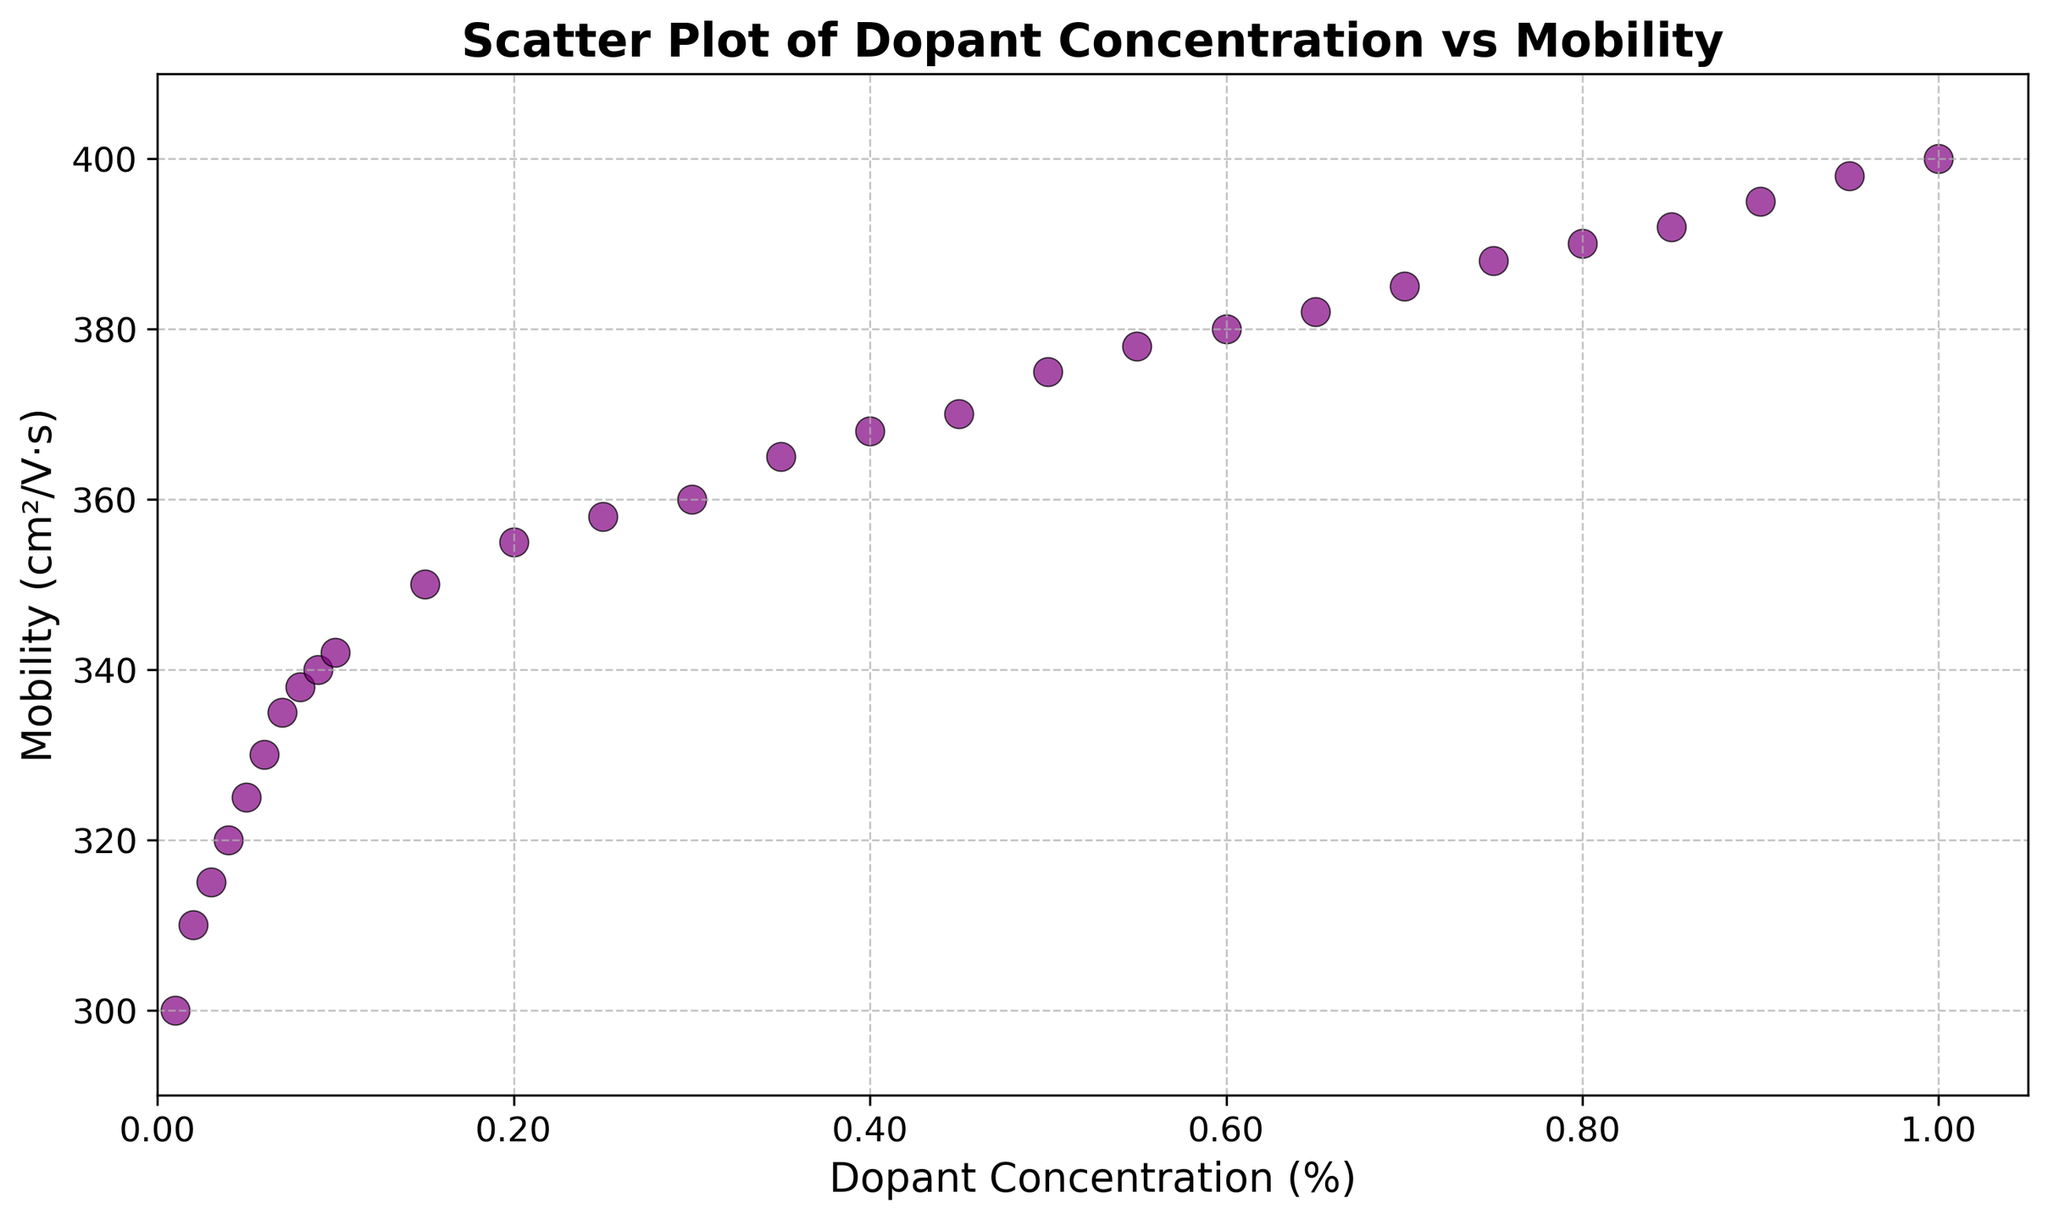What is the mobility at a dopant concentration of 0.30%? Look for the data point on the scatter plot where the x-value (dopant concentration) is 0.30% and read the corresponding y-value (mobility).
Answer: 360 Does mobility increase steadily with dopant concentration? Observe the trend of data points; check if the y-values (mobility) consistently increase as the x-values (dopant concentration) increase.
Answer: Yes What is the difference in mobility between dopant concentrations of 0.05% and 0.20%? Find the y-values for dopant concentrations of 0.05% and 0.20%. The mobility at 0.05% is 325 and at 0.20% is 355. Calculate the difference: 355 - 325.
Answer: 30 Which dopant concentration shows the highest mobility? Identify the data point on the scatter plot with the highest y-value (mobility). The highest point is at a dopant concentration of 1.00%.
Answer: 1.00% At which dopant concentration does mobility first exceed 350? Find the smallest x-value (dopant concentration) for which the y-value (mobility) is greater than 350. This is where the scatter point first crosses the 350 line.
Answer: 0.15% Compare the mobility at 0.04% and 0.75% dopant concentrations. Which one is higher and by how much? Look for the mobility values at 0.04% and 0.75% dopant concentrations, which are 320 and 388 respectively. Calculate the difference: 388 - 320.
Answer: 0.75% is higher by 68 Does the scatter plot suggest a linear relationship between dopant concentration and mobility? Observe the alignment of data points; if they form a roughly straight line, it's indicative of a linear relationship. The points appear to increase consistently, suggesting a linear relationship.
Answer: Yes Calculate the average mobility for dopant concentrations of 0.01%, 0.50%, and 1.00%. Find the y-values for dopant concentrations of 0.01%, 0.50%, and 1.00%, which are 300, 375, and 400. Calculate the average: (300 + 375 + 400) / 3.
Answer: 358.33 What visual attributes differentiate the data points on the scatter plot? Identify visual characteristics such as color, edge color, size, and marker shape. The data points are purple with black edges, medium-sized, and circular.
Answer: Color, edge color, size, and marker shape Is there any dopant concentration where mobility remains almost constant? Scan the plot for segments where the y-values (mobility) remain approximately the same despite changes in x-values (dopant concentration). There isn't a segment where mobility remains constant; it gradually increases.
Answer: No 